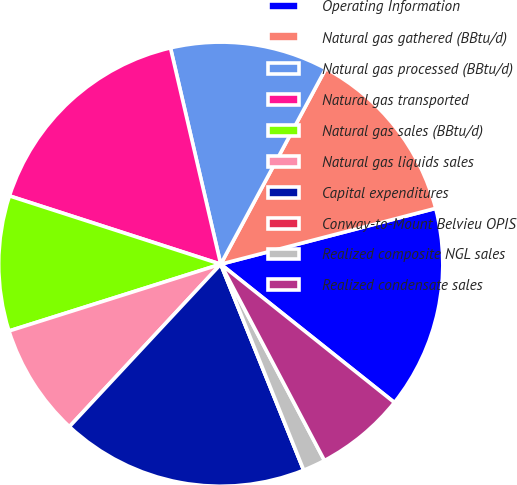Convert chart to OTSL. <chart><loc_0><loc_0><loc_500><loc_500><pie_chart><fcel>Operating Information<fcel>Natural gas gathered (BBtu/d)<fcel>Natural gas processed (BBtu/d)<fcel>Natural gas transported<fcel>Natural gas sales (BBtu/d)<fcel>Natural gas liquids sales<fcel>Capital expenditures<fcel>Conway-to-Mount Belvieu OPIS<fcel>Realized composite NGL sales<fcel>Realized condensate sales<nl><fcel>14.75%<fcel>13.11%<fcel>11.48%<fcel>16.39%<fcel>9.84%<fcel>8.2%<fcel>18.03%<fcel>0.0%<fcel>1.64%<fcel>6.56%<nl></chart> 